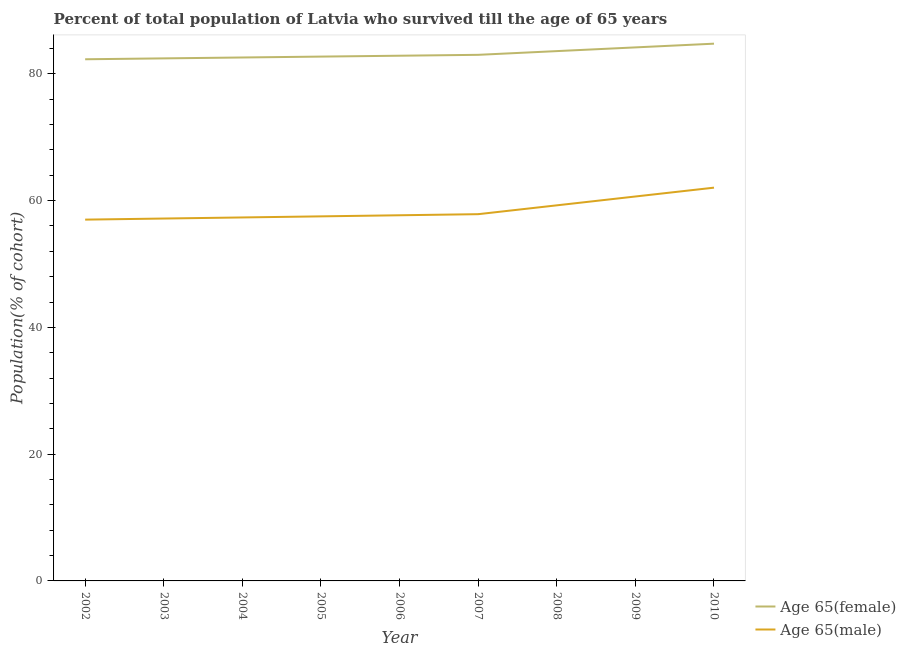How many different coloured lines are there?
Provide a short and direct response. 2. Does the line corresponding to percentage of female population who survived till age of 65 intersect with the line corresponding to percentage of male population who survived till age of 65?
Offer a very short reply. No. Is the number of lines equal to the number of legend labels?
Keep it short and to the point. Yes. What is the percentage of male population who survived till age of 65 in 2010?
Keep it short and to the point. 62.04. Across all years, what is the maximum percentage of male population who survived till age of 65?
Offer a terse response. 62.04. Across all years, what is the minimum percentage of male population who survived till age of 65?
Give a very brief answer. 57. In which year was the percentage of male population who survived till age of 65 maximum?
Keep it short and to the point. 2010. In which year was the percentage of female population who survived till age of 65 minimum?
Your response must be concise. 2002. What is the total percentage of male population who survived till age of 65 in the graph?
Offer a terse response. 526.51. What is the difference between the percentage of female population who survived till age of 65 in 2006 and that in 2010?
Make the answer very short. -1.9. What is the difference between the percentage of female population who survived till age of 65 in 2007 and the percentage of male population who survived till age of 65 in 2008?
Your response must be concise. 23.74. What is the average percentage of male population who survived till age of 65 per year?
Offer a very short reply. 58.5. In the year 2005, what is the difference between the percentage of female population who survived till age of 65 and percentage of male population who survived till age of 65?
Make the answer very short. 25.2. In how many years, is the percentage of male population who survived till age of 65 greater than 32 %?
Provide a short and direct response. 9. What is the ratio of the percentage of male population who survived till age of 65 in 2002 to that in 2009?
Ensure brevity in your answer.  0.94. Is the difference between the percentage of male population who survived till age of 65 in 2004 and 2007 greater than the difference between the percentage of female population who survived till age of 65 in 2004 and 2007?
Your answer should be compact. No. What is the difference between the highest and the second highest percentage of male population who survived till age of 65?
Provide a short and direct response. 1.39. What is the difference between the highest and the lowest percentage of male population who survived till age of 65?
Your answer should be compact. 5.04. In how many years, is the percentage of female population who survived till age of 65 greater than the average percentage of female population who survived till age of 65 taken over all years?
Provide a short and direct response. 3. Does the percentage of male population who survived till age of 65 monotonically increase over the years?
Keep it short and to the point. Yes. Is the percentage of male population who survived till age of 65 strictly greater than the percentage of female population who survived till age of 65 over the years?
Provide a succinct answer. No. Is the percentage of female population who survived till age of 65 strictly less than the percentage of male population who survived till age of 65 over the years?
Make the answer very short. No. How many years are there in the graph?
Your response must be concise. 9. Where does the legend appear in the graph?
Ensure brevity in your answer.  Bottom right. How many legend labels are there?
Your answer should be compact. 2. What is the title of the graph?
Offer a very short reply. Percent of total population of Latvia who survived till the age of 65 years. Does "RDB nonconcessional" appear as one of the legend labels in the graph?
Provide a short and direct response. No. What is the label or title of the X-axis?
Your answer should be compact. Year. What is the label or title of the Y-axis?
Ensure brevity in your answer.  Population(% of cohort). What is the Population(% of cohort) of Age 65(female) in 2002?
Your answer should be very brief. 82.3. What is the Population(% of cohort) of Age 65(male) in 2002?
Ensure brevity in your answer.  57. What is the Population(% of cohort) of Age 65(female) in 2003?
Offer a terse response. 82.44. What is the Population(% of cohort) of Age 65(male) in 2003?
Your response must be concise. 57.17. What is the Population(% of cohort) in Age 65(female) in 2004?
Offer a terse response. 82.58. What is the Population(% of cohort) in Age 65(male) in 2004?
Your answer should be very brief. 57.34. What is the Population(% of cohort) in Age 65(female) in 2005?
Your answer should be compact. 82.72. What is the Population(% of cohort) of Age 65(male) in 2005?
Your answer should be very brief. 57.51. What is the Population(% of cohort) of Age 65(female) in 2006?
Make the answer very short. 82.86. What is the Population(% of cohort) in Age 65(male) in 2006?
Give a very brief answer. 57.69. What is the Population(% of cohort) of Age 65(female) in 2007?
Offer a very short reply. 83. What is the Population(% of cohort) in Age 65(male) in 2007?
Provide a succinct answer. 57.86. What is the Population(% of cohort) of Age 65(female) in 2008?
Keep it short and to the point. 83.58. What is the Population(% of cohort) of Age 65(male) in 2008?
Your answer should be very brief. 59.25. What is the Population(% of cohort) in Age 65(female) in 2009?
Give a very brief answer. 84.17. What is the Population(% of cohort) of Age 65(male) in 2009?
Offer a very short reply. 60.65. What is the Population(% of cohort) in Age 65(female) in 2010?
Offer a terse response. 84.76. What is the Population(% of cohort) of Age 65(male) in 2010?
Keep it short and to the point. 62.04. Across all years, what is the maximum Population(% of cohort) in Age 65(female)?
Offer a very short reply. 84.76. Across all years, what is the maximum Population(% of cohort) of Age 65(male)?
Ensure brevity in your answer.  62.04. Across all years, what is the minimum Population(% of cohort) in Age 65(female)?
Ensure brevity in your answer.  82.3. Across all years, what is the minimum Population(% of cohort) of Age 65(male)?
Offer a terse response. 57. What is the total Population(% of cohort) in Age 65(female) in the graph?
Provide a succinct answer. 748.39. What is the total Population(% of cohort) of Age 65(male) in the graph?
Your answer should be very brief. 526.51. What is the difference between the Population(% of cohort) of Age 65(female) in 2002 and that in 2003?
Make the answer very short. -0.14. What is the difference between the Population(% of cohort) in Age 65(male) in 2002 and that in 2003?
Offer a terse response. -0.17. What is the difference between the Population(% of cohort) of Age 65(female) in 2002 and that in 2004?
Give a very brief answer. -0.28. What is the difference between the Population(% of cohort) in Age 65(male) in 2002 and that in 2004?
Make the answer very short. -0.34. What is the difference between the Population(% of cohort) in Age 65(female) in 2002 and that in 2005?
Offer a terse response. -0.42. What is the difference between the Population(% of cohort) of Age 65(male) in 2002 and that in 2005?
Make the answer very short. -0.52. What is the difference between the Population(% of cohort) in Age 65(female) in 2002 and that in 2006?
Your answer should be very brief. -0.56. What is the difference between the Population(% of cohort) of Age 65(male) in 2002 and that in 2006?
Your answer should be compact. -0.69. What is the difference between the Population(% of cohort) in Age 65(female) in 2002 and that in 2007?
Offer a terse response. -0.7. What is the difference between the Population(% of cohort) in Age 65(male) in 2002 and that in 2007?
Your response must be concise. -0.86. What is the difference between the Population(% of cohort) in Age 65(female) in 2002 and that in 2008?
Provide a short and direct response. -1.29. What is the difference between the Population(% of cohort) in Age 65(male) in 2002 and that in 2008?
Your response must be concise. -2.25. What is the difference between the Population(% of cohort) in Age 65(female) in 2002 and that in 2009?
Give a very brief answer. -1.87. What is the difference between the Population(% of cohort) of Age 65(male) in 2002 and that in 2009?
Your answer should be very brief. -3.65. What is the difference between the Population(% of cohort) in Age 65(female) in 2002 and that in 2010?
Ensure brevity in your answer.  -2.46. What is the difference between the Population(% of cohort) in Age 65(male) in 2002 and that in 2010?
Make the answer very short. -5.04. What is the difference between the Population(% of cohort) of Age 65(female) in 2003 and that in 2004?
Provide a succinct answer. -0.14. What is the difference between the Population(% of cohort) of Age 65(male) in 2003 and that in 2004?
Offer a very short reply. -0.17. What is the difference between the Population(% of cohort) in Age 65(female) in 2003 and that in 2005?
Offer a very short reply. -0.28. What is the difference between the Population(% of cohort) in Age 65(male) in 2003 and that in 2005?
Provide a succinct answer. -0.34. What is the difference between the Population(% of cohort) in Age 65(female) in 2003 and that in 2006?
Your answer should be compact. -0.42. What is the difference between the Population(% of cohort) of Age 65(male) in 2003 and that in 2006?
Keep it short and to the point. -0.52. What is the difference between the Population(% of cohort) of Age 65(female) in 2003 and that in 2007?
Keep it short and to the point. -0.56. What is the difference between the Population(% of cohort) of Age 65(male) in 2003 and that in 2007?
Your answer should be very brief. -0.69. What is the difference between the Population(% of cohort) of Age 65(female) in 2003 and that in 2008?
Provide a succinct answer. -1.15. What is the difference between the Population(% of cohort) in Age 65(male) in 2003 and that in 2008?
Provide a short and direct response. -2.08. What is the difference between the Population(% of cohort) of Age 65(female) in 2003 and that in 2009?
Provide a succinct answer. -1.73. What is the difference between the Population(% of cohort) in Age 65(male) in 2003 and that in 2009?
Give a very brief answer. -3.48. What is the difference between the Population(% of cohort) in Age 65(female) in 2003 and that in 2010?
Offer a very short reply. -2.32. What is the difference between the Population(% of cohort) in Age 65(male) in 2003 and that in 2010?
Your answer should be compact. -4.87. What is the difference between the Population(% of cohort) of Age 65(female) in 2004 and that in 2005?
Your response must be concise. -0.14. What is the difference between the Population(% of cohort) in Age 65(male) in 2004 and that in 2005?
Provide a short and direct response. -0.17. What is the difference between the Population(% of cohort) of Age 65(female) in 2004 and that in 2006?
Keep it short and to the point. -0.28. What is the difference between the Population(% of cohort) in Age 65(male) in 2004 and that in 2006?
Make the answer very short. -0.34. What is the difference between the Population(% of cohort) in Age 65(female) in 2004 and that in 2007?
Provide a short and direct response. -0.42. What is the difference between the Population(% of cohort) in Age 65(male) in 2004 and that in 2007?
Your answer should be compact. -0.52. What is the difference between the Population(% of cohort) of Age 65(female) in 2004 and that in 2008?
Provide a short and direct response. -1.01. What is the difference between the Population(% of cohort) of Age 65(male) in 2004 and that in 2008?
Offer a terse response. -1.91. What is the difference between the Population(% of cohort) in Age 65(female) in 2004 and that in 2009?
Your answer should be compact. -1.59. What is the difference between the Population(% of cohort) in Age 65(male) in 2004 and that in 2009?
Keep it short and to the point. -3.3. What is the difference between the Population(% of cohort) in Age 65(female) in 2004 and that in 2010?
Your response must be concise. -2.18. What is the difference between the Population(% of cohort) in Age 65(male) in 2004 and that in 2010?
Give a very brief answer. -4.7. What is the difference between the Population(% of cohort) in Age 65(female) in 2005 and that in 2006?
Offer a terse response. -0.14. What is the difference between the Population(% of cohort) of Age 65(male) in 2005 and that in 2006?
Give a very brief answer. -0.17. What is the difference between the Population(% of cohort) in Age 65(female) in 2005 and that in 2007?
Ensure brevity in your answer.  -0.28. What is the difference between the Population(% of cohort) in Age 65(male) in 2005 and that in 2007?
Provide a short and direct response. -0.34. What is the difference between the Population(% of cohort) in Age 65(female) in 2005 and that in 2008?
Your answer should be compact. -0.87. What is the difference between the Population(% of cohort) in Age 65(male) in 2005 and that in 2008?
Give a very brief answer. -1.74. What is the difference between the Population(% of cohort) in Age 65(female) in 2005 and that in 2009?
Ensure brevity in your answer.  -1.45. What is the difference between the Population(% of cohort) in Age 65(male) in 2005 and that in 2009?
Your response must be concise. -3.13. What is the difference between the Population(% of cohort) of Age 65(female) in 2005 and that in 2010?
Provide a succinct answer. -2.04. What is the difference between the Population(% of cohort) of Age 65(male) in 2005 and that in 2010?
Provide a short and direct response. -4.53. What is the difference between the Population(% of cohort) of Age 65(female) in 2006 and that in 2007?
Keep it short and to the point. -0.14. What is the difference between the Population(% of cohort) in Age 65(male) in 2006 and that in 2007?
Provide a short and direct response. -0.17. What is the difference between the Population(% of cohort) of Age 65(female) in 2006 and that in 2008?
Offer a very short reply. -0.73. What is the difference between the Population(% of cohort) in Age 65(male) in 2006 and that in 2008?
Your answer should be compact. -1.57. What is the difference between the Population(% of cohort) of Age 65(female) in 2006 and that in 2009?
Make the answer very short. -1.31. What is the difference between the Population(% of cohort) in Age 65(male) in 2006 and that in 2009?
Ensure brevity in your answer.  -2.96. What is the difference between the Population(% of cohort) in Age 65(female) in 2006 and that in 2010?
Your response must be concise. -1.9. What is the difference between the Population(% of cohort) of Age 65(male) in 2006 and that in 2010?
Keep it short and to the point. -4.36. What is the difference between the Population(% of cohort) of Age 65(female) in 2007 and that in 2008?
Provide a short and direct response. -0.59. What is the difference between the Population(% of cohort) in Age 65(male) in 2007 and that in 2008?
Your answer should be compact. -1.39. What is the difference between the Population(% of cohort) of Age 65(female) in 2007 and that in 2009?
Ensure brevity in your answer.  -1.17. What is the difference between the Population(% of cohort) in Age 65(male) in 2007 and that in 2009?
Provide a short and direct response. -2.79. What is the difference between the Population(% of cohort) of Age 65(female) in 2007 and that in 2010?
Give a very brief answer. -1.76. What is the difference between the Population(% of cohort) of Age 65(male) in 2007 and that in 2010?
Offer a very short reply. -4.18. What is the difference between the Population(% of cohort) in Age 65(female) in 2008 and that in 2009?
Give a very brief answer. -0.59. What is the difference between the Population(% of cohort) in Age 65(male) in 2008 and that in 2009?
Give a very brief answer. -1.39. What is the difference between the Population(% of cohort) in Age 65(female) in 2008 and that in 2010?
Your response must be concise. -1.17. What is the difference between the Population(% of cohort) in Age 65(male) in 2008 and that in 2010?
Offer a very short reply. -2.79. What is the difference between the Population(% of cohort) of Age 65(female) in 2009 and that in 2010?
Make the answer very short. -0.59. What is the difference between the Population(% of cohort) of Age 65(male) in 2009 and that in 2010?
Your answer should be compact. -1.39. What is the difference between the Population(% of cohort) in Age 65(female) in 2002 and the Population(% of cohort) in Age 65(male) in 2003?
Provide a succinct answer. 25.13. What is the difference between the Population(% of cohort) in Age 65(female) in 2002 and the Population(% of cohort) in Age 65(male) in 2004?
Offer a terse response. 24.95. What is the difference between the Population(% of cohort) of Age 65(female) in 2002 and the Population(% of cohort) of Age 65(male) in 2005?
Offer a terse response. 24.78. What is the difference between the Population(% of cohort) of Age 65(female) in 2002 and the Population(% of cohort) of Age 65(male) in 2006?
Ensure brevity in your answer.  24.61. What is the difference between the Population(% of cohort) of Age 65(female) in 2002 and the Population(% of cohort) of Age 65(male) in 2007?
Offer a terse response. 24.44. What is the difference between the Population(% of cohort) of Age 65(female) in 2002 and the Population(% of cohort) of Age 65(male) in 2008?
Your answer should be compact. 23.04. What is the difference between the Population(% of cohort) in Age 65(female) in 2002 and the Population(% of cohort) in Age 65(male) in 2009?
Your response must be concise. 21.65. What is the difference between the Population(% of cohort) of Age 65(female) in 2002 and the Population(% of cohort) of Age 65(male) in 2010?
Give a very brief answer. 20.26. What is the difference between the Population(% of cohort) in Age 65(female) in 2003 and the Population(% of cohort) in Age 65(male) in 2004?
Make the answer very short. 25.09. What is the difference between the Population(% of cohort) of Age 65(female) in 2003 and the Population(% of cohort) of Age 65(male) in 2005?
Give a very brief answer. 24.92. What is the difference between the Population(% of cohort) in Age 65(female) in 2003 and the Population(% of cohort) in Age 65(male) in 2006?
Ensure brevity in your answer.  24.75. What is the difference between the Population(% of cohort) of Age 65(female) in 2003 and the Population(% of cohort) of Age 65(male) in 2007?
Ensure brevity in your answer.  24.58. What is the difference between the Population(% of cohort) of Age 65(female) in 2003 and the Population(% of cohort) of Age 65(male) in 2008?
Offer a very short reply. 23.18. What is the difference between the Population(% of cohort) in Age 65(female) in 2003 and the Population(% of cohort) in Age 65(male) in 2009?
Your answer should be compact. 21.79. What is the difference between the Population(% of cohort) in Age 65(female) in 2003 and the Population(% of cohort) in Age 65(male) in 2010?
Make the answer very short. 20.4. What is the difference between the Population(% of cohort) of Age 65(female) in 2004 and the Population(% of cohort) of Age 65(male) in 2005?
Offer a terse response. 25.06. What is the difference between the Population(% of cohort) in Age 65(female) in 2004 and the Population(% of cohort) in Age 65(male) in 2006?
Provide a short and direct response. 24.89. What is the difference between the Population(% of cohort) in Age 65(female) in 2004 and the Population(% of cohort) in Age 65(male) in 2007?
Your response must be concise. 24.72. What is the difference between the Population(% of cohort) in Age 65(female) in 2004 and the Population(% of cohort) in Age 65(male) in 2008?
Ensure brevity in your answer.  23.32. What is the difference between the Population(% of cohort) in Age 65(female) in 2004 and the Population(% of cohort) in Age 65(male) in 2009?
Keep it short and to the point. 21.93. What is the difference between the Population(% of cohort) in Age 65(female) in 2004 and the Population(% of cohort) in Age 65(male) in 2010?
Ensure brevity in your answer.  20.54. What is the difference between the Population(% of cohort) of Age 65(female) in 2005 and the Population(% of cohort) of Age 65(male) in 2006?
Make the answer very short. 25.03. What is the difference between the Population(% of cohort) in Age 65(female) in 2005 and the Population(% of cohort) in Age 65(male) in 2007?
Offer a very short reply. 24.86. What is the difference between the Population(% of cohort) in Age 65(female) in 2005 and the Population(% of cohort) in Age 65(male) in 2008?
Offer a terse response. 23.46. What is the difference between the Population(% of cohort) of Age 65(female) in 2005 and the Population(% of cohort) of Age 65(male) in 2009?
Your answer should be very brief. 22.07. What is the difference between the Population(% of cohort) in Age 65(female) in 2005 and the Population(% of cohort) in Age 65(male) in 2010?
Ensure brevity in your answer.  20.68. What is the difference between the Population(% of cohort) of Age 65(female) in 2006 and the Population(% of cohort) of Age 65(male) in 2007?
Provide a short and direct response. 25. What is the difference between the Population(% of cohort) of Age 65(female) in 2006 and the Population(% of cohort) of Age 65(male) in 2008?
Provide a succinct answer. 23.6. What is the difference between the Population(% of cohort) in Age 65(female) in 2006 and the Population(% of cohort) in Age 65(male) in 2009?
Offer a terse response. 22.21. What is the difference between the Population(% of cohort) of Age 65(female) in 2006 and the Population(% of cohort) of Age 65(male) in 2010?
Give a very brief answer. 20.82. What is the difference between the Population(% of cohort) of Age 65(female) in 2007 and the Population(% of cohort) of Age 65(male) in 2008?
Your answer should be very brief. 23.74. What is the difference between the Population(% of cohort) of Age 65(female) in 2007 and the Population(% of cohort) of Age 65(male) in 2009?
Make the answer very short. 22.35. What is the difference between the Population(% of cohort) of Age 65(female) in 2007 and the Population(% of cohort) of Age 65(male) in 2010?
Offer a terse response. 20.96. What is the difference between the Population(% of cohort) of Age 65(female) in 2008 and the Population(% of cohort) of Age 65(male) in 2009?
Your response must be concise. 22.94. What is the difference between the Population(% of cohort) of Age 65(female) in 2008 and the Population(% of cohort) of Age 65(male) in 2010?
Offer a very short reply. 21.54. What is the difference between the Population(% of cohort) of Age 65(female) in 2009 and the Population(% of cohort) of Age 65(male) in 2010?
Your response must be concise. 22.13. What is the average Population(% of cohort) in Age 65(female) per year?
Ensure brevity in your answer.  83.15. What is the average Population(% of cohort) of Age 65(male) per year?
Provide a short and direct response. 58.5. In the year 2002, what is the difference between the Population(% of cohort) of Age 65(female) and Population(% of cohort) of Age 65(male)?
Give a very brief answer. 25.3. In the year 2003, what is the difference between the Population(% of cohort) of Age 65(female) and Population(% of cohort) of Age 65(male)?
Provide a short and direct response. 25.27. In the year 2004, what is the difference between the Population(% of cohort) in Age 65(female) and Population(% of cohort) in Age 65(male)?
Offer a very short reply. 25.23. In the year 2005, what is the difference between the Population(% of cohort) of Age 65(female) and Population(% of cohort) of Age 65(male)?
Provide a succinct answer. 25.2. In the year 2006, what is the difference between the Population(% of cohort) in Age 65(female) and Population(% of cohort) in Age 65(male)?
Provide a short and direct response. 25.17. In the year 2007, what is the difference between the Population(% of cohort) of Age 65(female) and Population(% of cohort) of Age 65(male)?
Provide a short and direct response. 25.14. In the year 2008, what is the difference between the Population(% of cohort) in Age 65(female) and Population(% of cohort) in Age 65(male)?
Provide a short and direct response. 24.33. In the year 2009, what is the difference between the Population(% of cohort) in Age 65(female) and Population(% of cohort) in Age 65(male)?
Your answer should be very brief. 23.52. In the year 2010, what is the difference between the Population(% of cohort) in Age 65(female) and Population(% of cohort) in Age 65(male)?
Keep it short and to the point. 22.71. What is the ratio of the Population(% of cohort) in Age 65(male) in 2002 to that in 2003?
Keep it short and to the point. 1. What is the ratio of the Population(% of cohort) of Age 65(male) in 2002 to that in 2005?
Your answer should be compact. 0.99. What is the ratio of the Population(% of cohort) of Age 65(female) in 2002 to that in 2006?
Provide a short and direct response. 0.99. What is the ratio of the Population(% of cohort) in Age 65(male) in 2002 to that in 2006?
Keep it short and to the point. 0.99. What is the ratio of the Population(% of cohort) in Age 65(male) in 2002 to that in 2007?
Provide a succinct answer. 0.99. What is the ratio of the Population(% of cohort) of Age 65(female) in 2002 to that in 2008?
Offer a very short reply. 0.98. What is the ratio of the Population(% of cohort) in Age 65(female) in 2002 to that in 2009?
Offer a terse response. 0.98. What is the ratio of the Population(% of cohort) of Age 65(male) in 2002 to that in 2009?
Your response must be concise. 0.94. What is the ratio of the Population(% of cohort) of Age 65(female) in 2002 to that in 2010?
Offer a terse response. 0.97. What is the ratio of the Population(% of cohort) in Age 65(male) in 2002 to that in 2010?
Offer a terse response. 0.92. What is the ratio of the Population(% of cohort) of Age 65(female) in 2003 to that in 2004?
Offer a very short reply. 1. What is the ratio of the Population(% of cohort) in Age 65(male) in 2003 to that in 2004?
Offer a very short reply. 1. What is the ratio of the Population(% of cohort) of Age 65(male) in 2003 to that in 2005?
Keep it short and to the point. 0.99. What is the ratio of the Population(% of cohort) in Age 65(female) in 2003 to that in 2006?
Your answer should be compact. 0.99. What is the ratio of the Population(% of cohort) of Age 65(female) in 2003 to that in 2007?
Offer a very short reply. 0.99. What is the ratio of the Population(% of cohort) of Age 65(female) in 2003 to that in 2008?
Keep it short and to the point. 0.99. What is the ratio of the Population(% of cohort) in Age 65(male) in 2003 to that in 2008?
Make the answer very short. 0.96. What is the ratio of the Population(% of cohort) in Age 65(female) in 2003 to that in 2009?
Keep it short and to the point. 0.98. What is the ratio of the Population(% of cohort) of Age 65(male) in 2003 to that in 2009?
Keep it short and to the point. 0.94. What is the ratio of the Population(% of cohort) of Age 65(female) in 2003 to that in 2010?
Offer a terse response. 0.97. What is the ratio of the Population(% of cohort) of Age 65(male) in 2003 to that in 2010?
Make the answer very short. 0.92. What is the ratio of the Population(% of cohort) of Age 65(male) in 2004 to that in 2005?
Your response must be concise. 1. What is the ratio of the Population(% of cohort) of Age 65(female) in 2004 to that in 2006?
Ensure brevity in your answer.  1. What is the ratio of the Population(% of cohort) in Age 65(male) in 2004 to that in 2006?
Provide a short and direct response. 0.99. What is the ratio of the Population(% of cohort) of Age 65(male) in 2004 to that in 2007?
Give a very brief answer. 0.99. What is the ratio of the Population(% of cohort) of Age 65(female) in 2004 to that in 2008?
Offer a terse response. 0.99. What is the ratio of the Population(% of cohort) of Age 65(male) in 2004 to that in 2008?
Your response must be concise. 0.97. What is the ratio of the Population(% of cohort) of Age 65(female) in 2004 to that in 2009?
Make the answer very short. 0.98. What is the ratio of the Population(% of cohort) in Age 65(male) in 2004 to that in 2009?
Keep it short and to the point. 0.95. What is the ratio of the Population(% of cohort) of Age 65(female) in 2004 to that in 2010?
Provide a short and direct response. 0.97. What is the ratio of the Population(% of cohort) in Age 65(male) in 2004 to that in 2010?
Provide a short and direct response. 0.92. What is the ratio of the Population(% of cohort) in Age 65(female) in 2005 to that in 2006?
Provide a short and direct response. 1. What is the ratio of the Population(% of cohort) in Age 65(male) in 2005 to that in 2006?
Make the answer very short. 1. What is the ratio of the Population(% of cohort) in Age 65(female) in 2005 to that in 2007?
Offer a terse response. 1. What is the ratio of the Population(% of cohort) of Age 65(male) in 2005 to that in 2007?
Offer a very short reply. 0.99. What is the ratio of the Population(% of cohort) in Age 65(male) in 2005 to that in 2008?
Make the answer very short. 0.97. What is the ratio of the Population(% of cohort) of Age 65(female) in 2005 to that in 2009?
Offer a very short reply. 0.98. What is the ratio of the Population(% of cohort) of Age 65(male) in 2005 to that in 2009?
Keep it short and to the point. 0.95. What is the ratio of the Population(% of cohort) in Age 65(female) in 2005 to that in 2010?
Your answer should be very brief. 0.98. What is the ratio of the Population(% of cohort) of Age 65(male) in 2005 to that in 2010?
Keep it short and to the point. 0.93. What is the ratio of the Population(% of cohort) of Age 65(female) in 2006 to that in 2007?
Keep it short and to the point. 1. What is the ratio of the Population(% of cohort) of Age 65(female) in 2006 to that in 2008?
Your response must be concise. 0.99. What is the ratio of the Population(% of cohort) in Age 65(male) in 2006 to that in 2008?
Your answer should be very brief. 0.97. What is the ratio of the Population(% of cohort) in Age 65(female) in 2006 to that in 2009?
Ensure brevity in your answer.  0.98. What is the ratio of the Population(% of cohort) of Age 65(male) in 2006 to that in 2009?
Offer a terse response. 0.95. What is the ratio of the Population(% of cohort) in Age 65(female) in 2006 to that in 2010?
Provide a succinct answer. 0.98. What is the ratio of the Population(% of cohort) in Age 65(male) in 2006 to that in 2010?
Give a very brief answer. 0.93. What is the ratio of the Population(% of cohort) in Age 65(male) in 2007 to that in 2008?
Keep it short and to the point. 0.98. What is the ratio of the Population(% of cohort) of Age 65(female) in 2007 to that in 2009?
Ensure brevity in your answer.  0.99. What is the ratio of the Population(% of cohort) in Age 65(male) in 2007 to that in 2009?
Ensure brevity in your answer.  0.95. What is the ratio of the Population(% of cohort) in Age 65(female) in 2007 to that in 2010?
Offer a terse response. 0.98. What is the ratio of the Population(% of cohort) of Age 65(male) in 2007 to that in 2010?
Provide a succinct answer. 0.93. What is the ratio of the Population(% of cohort) of Age 65(male) in 2008 to that in 2009?
Keep it short and to the point. 0.98. What is the ratio of the Population(% of cohort) of Age 65(female) in 2008 to that in 2010?
Give a very brief answer. 0.99. What is the ratio of the Population(% of cohort) of Age 65(male) in 2008 to that in 2010?
Offer a terse response. 0.95. What is the ratio of the Population(% of cohort) in Age 65(female) in 2009 to that in 2010?
Provide a short and direct response. 0.99. What is the ratio of the Population(% of cohort) of Age 65(male) in 2009 to that in 2010?
Provide a short and direct response. 0.98. What is the difference between the highest and the second highest Population(% of cohort) in Age 65(female)?
Provide a succinct answer. 0.59. What is the difference between the highest and the second highest Population(% of cohort) in Age 65(male)?
Your answer should be compact. 1.39. What is the difference between the highest and the lowest Population(% of cohort) in Age 65(female)?
Offer a very short reply. 2.46. What is the difference between the highest and the lowest Population(% of cohort) of Age 65(male)?
Your answer should be compact. 5.04. 